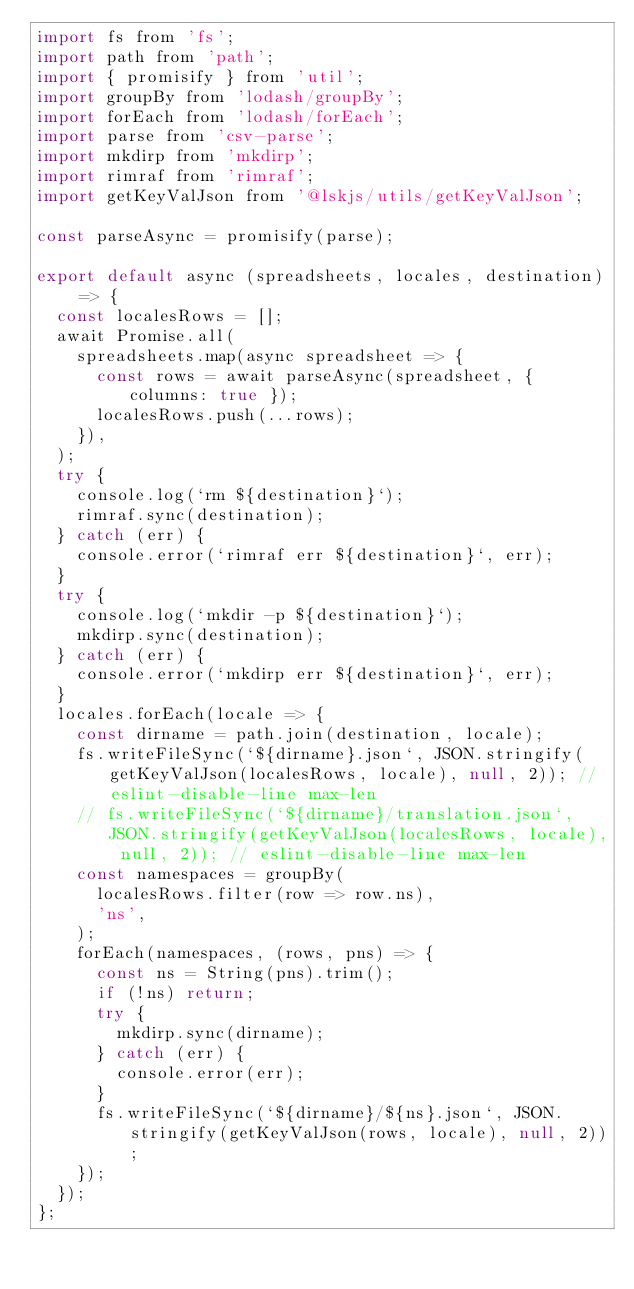<code> <loc_0><loc_0><loc_500><loc_500><_JavaScript_>import fs from 'fs';
import path from 'path';
import { promisify } from 'util';
import groupBy from 'lodash/groupBy';
import forEach from 'lodash/forEach';
import parse from 'csv-parse';
import mkdirp from 'mkdirp';
import rimraf from 'rimraf';
import getKeyValJson from '@lskjs/utils/getKeyValJson';

const parseAsync = promisify(parse);

export default async (spreadsheets, locales, destination) => {
  const localesRows = [];
  await Promise.all(
    spreadsheets.map(async spreadsheet => {
      const rows = await parseAsync(spreadsheet, { columns: true });
      localesRows.push(...rows);
    }),
  );
  try {
    console.log(`rm ${destination}`);
    rimraf.sync(destination);
  } catch (err) {
    console.error(`rimraf err ${destination}`, err);
  }
  try {
    console.log(`mkdir -p ${destination}`);
    mkdirp.sync(destination);
  } catch (err) {
    console.error(`mkdirp err ${destination}`, err);
  }
  locales.forEach(locale => {
    const dirname = path.join(destination, locale);
    fs.writeFileSync(`${dirname}.json`, JSON.stringify(getKeyValJson(localesRows, locale), null, 2)); // eslint-disable-line max-len
    // fs.writeFileSync(`${dirname}/translation.json`, JSON.stringify(getKeyValJson(localesRows, locale), null, 2)); // eslint-disable-line max-len
    const namespaces = groupBy(
      localesRows.filter(row => row.ns),
      'ns',
    );
    forEach(namespaces, (rows, pns) => {
      const ns = String(pns).trim();
      if (!ns) return;
      try {
        mkdirp.sync(dirname);
      } catch (err) {
        console.error(err);
      }
      fs.writeFileSync(`${dirname}/${ns}.json`, JSON.stringify(getKeyValJson(rows, locale), null, 2));
    });
  });
};
</code> 